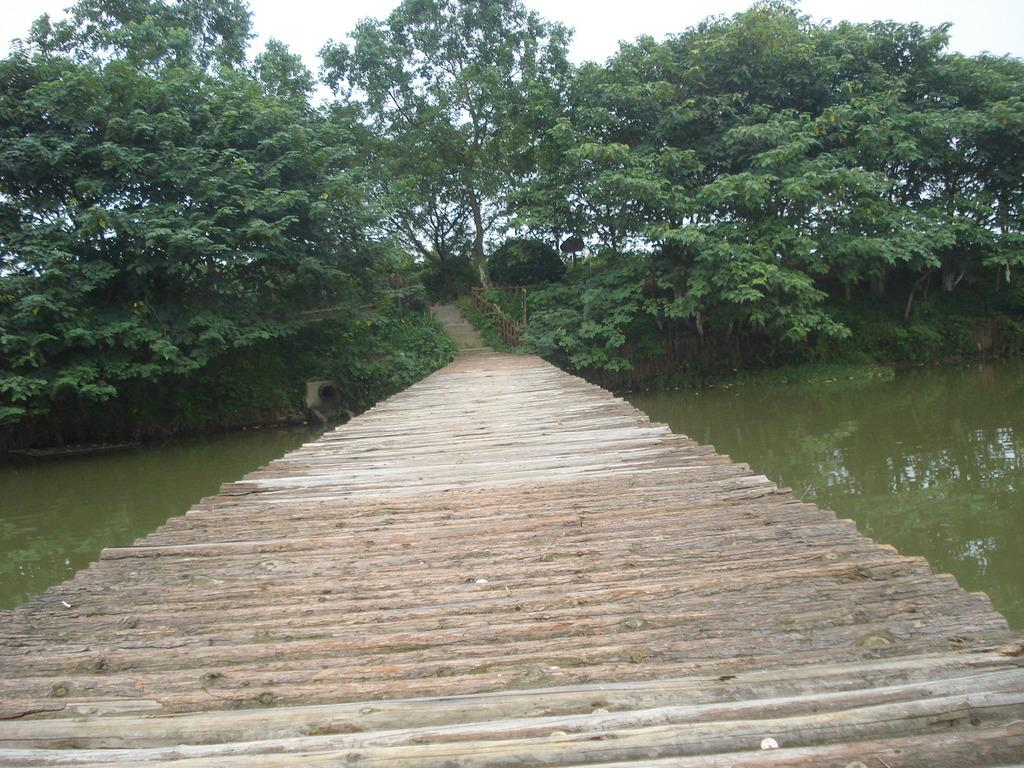What type of structure can be seen in the image? There is a bridge in the image. Are there any architectural features present in the image? Yes, there are stairs in the image. What natural element is visible in the image? Water is visible in the image. What is visible above the bridge and stairs? The sky is visible in the image. What type of oatmeal is being prepared on the bridge in the image? There is no oatmeal or any cooking activity present in the image. How does the match interact with the bridge in the image? There is no match or any fire-related activity present in the image. 